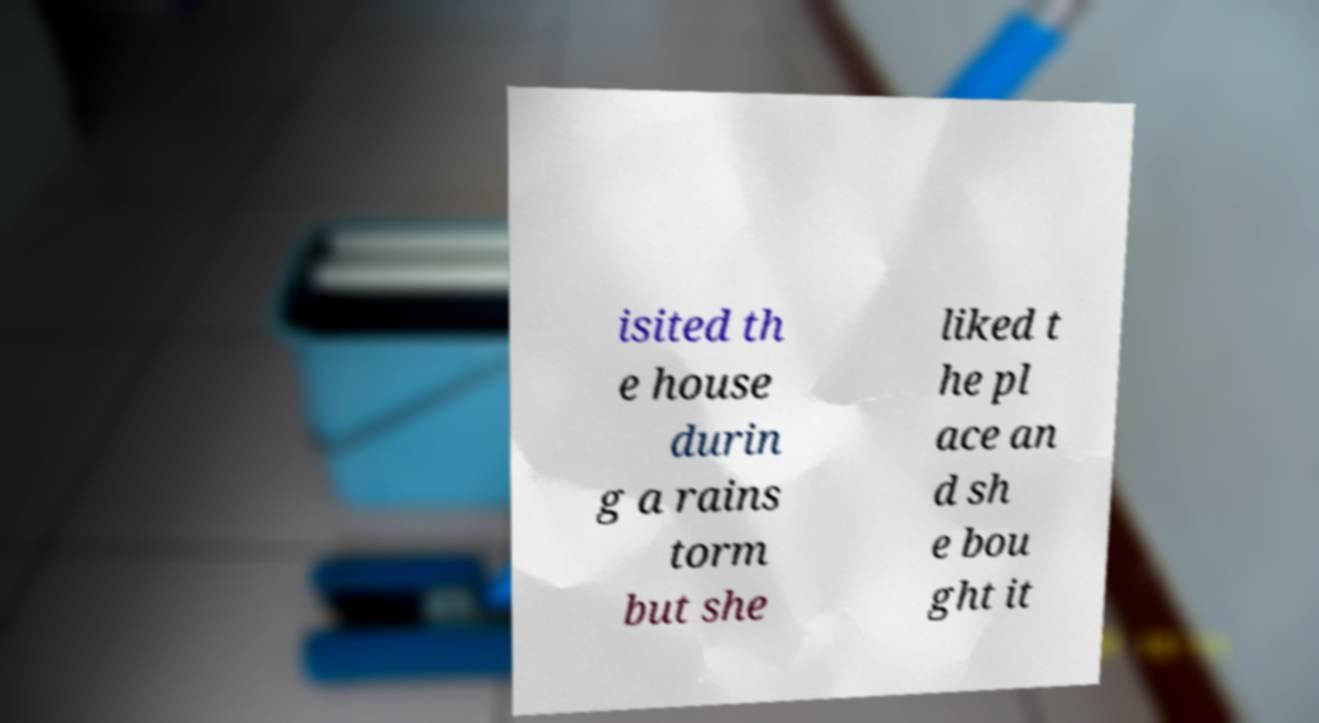Could you extract and type out the text from this image? isited th e house durin g a rains torm but she liked t he pl ace an d sh e bou ght it 